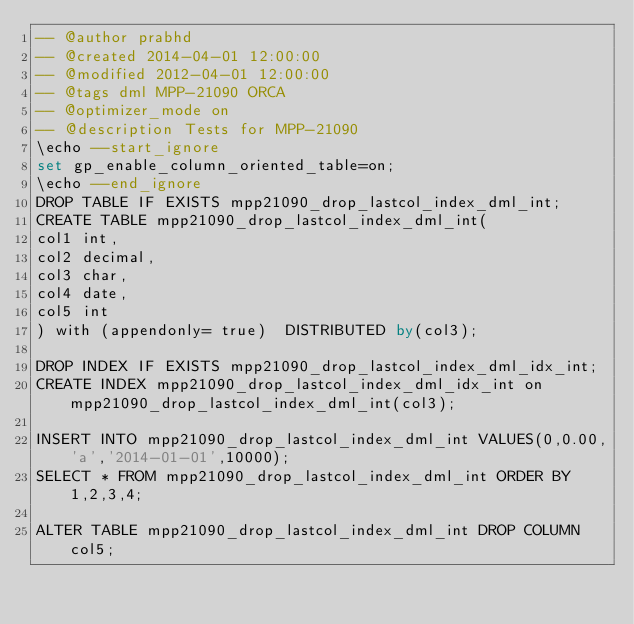<code> <loc_0><loc_0><loc_500><loc_500><_SQL_>-- @author prabhd 
-- @created 2014-04-01 12:00:00
-- @modified 2012-04-01 12:00:00
-- @tags dml MPP-21090 ORCA
-- @optimizer_mode on	
-- @description Tests for MPP-21090
\echo --start_ignore
set gp_enable_column_oriented_table=on;
\echo --end_ignore
DROP TABLE IF EXISTS mpp21090_drop_lastcol_index_dml_int;
CREATE TABLE mpp21090_drop_lastcol_index_dml_int(
col1 int,
col2 decimal,
col3 char,
col4 date,
col5 int
) with (appendonly= true)  DISTRIBUTED by(col3);

DROP INDEX IF EXISTS mpp21090_drop_lastcol_index_dml_idx_int;
CREATE INDEX mpp21090_drop_lastcol_index_dml_idx_int on mpp21090_drop_lastcol_index_dml_int(col3);

INSERT INTO mpp21090_drop_lastcol_index_dml_int VALUES(0,0.00,'a','2014-01-01',10000);
SELECT * FROM mpp21090_drop_lastcol_index_dml_int ORDER BY 1,2,3,4;

ALTER TABLE mpp21090_drop_lastcol_index_dml_int DROP COLUMN col5;
</code> 